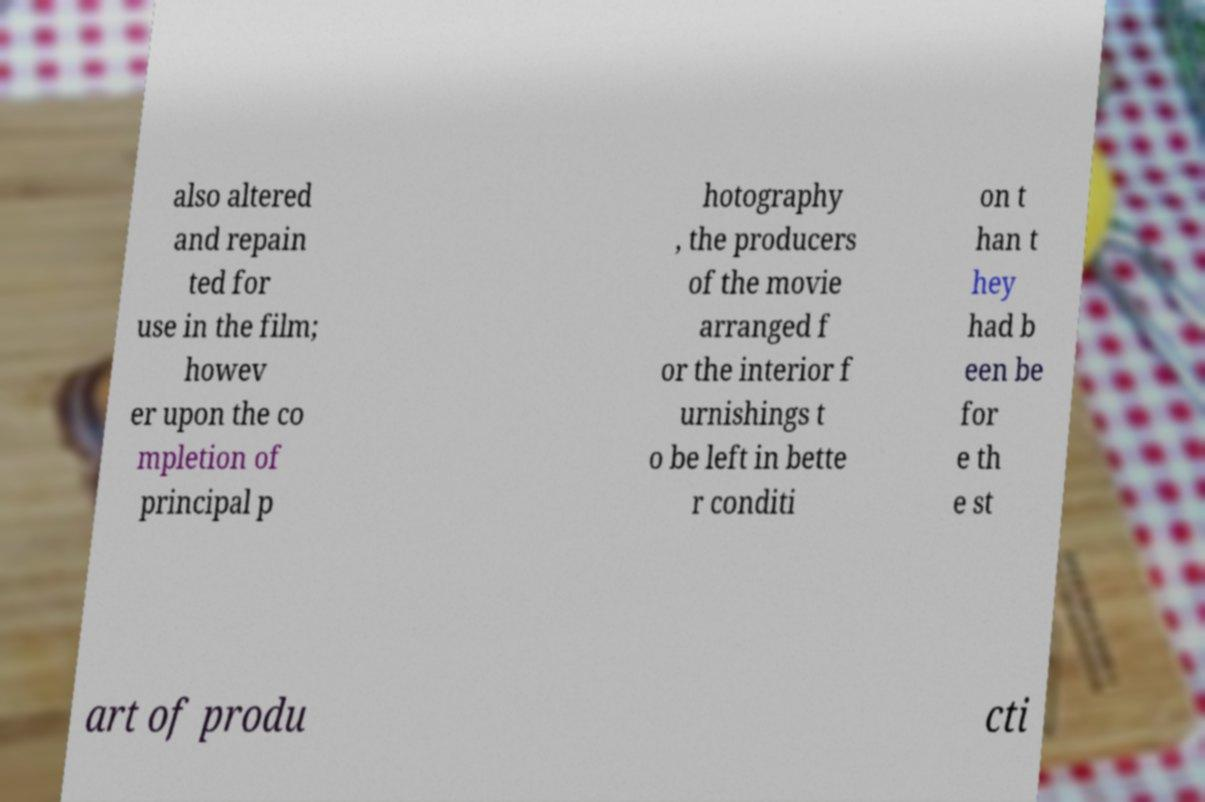What messages or text are displayed in this image? I need them in a readable, typed format. also altered and repain ted for use in the film; howev er upon the co mpletion of principal p hotography , the producers of the movie arranged f or the interior f urnishings t o be left in bette r conditi on t han t hey had b een be for e th e st art of produ cti 